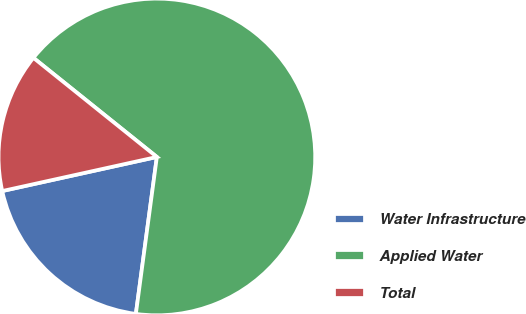Convert chart to OTSL. <chart><loc_0><loc_0><loc_500><loc_500><pie_chart><fcel>Water Infrastructure<fcel>Applied Water<fcel>Total<nl><fcel>19.43%<fcel>66.35%<fcel>14.22%<nl></chart> 